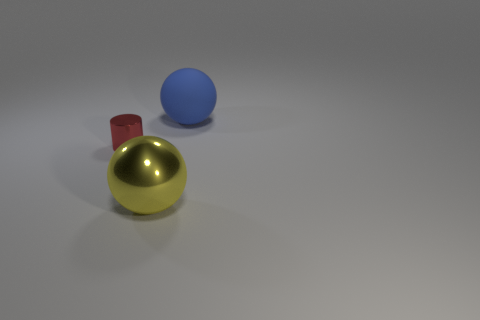There is a object that is in front of the red shiny cylinder; what shape is it?
Give a very brief answer. Sphere. Is the number of small red objects left of the shiny cylinder the same as the number of red cylinders on the left side of the metal ball?
Your answer should be compact. No. How many things are blue spheres or large spheres to the right of the large shiny object?
Offer a very short reply. 1. What shape is the object that is both left of the large rubber thing and behind the big yellow thing?
Offer a terse response. Cylinder. What material is the large sphere right of the large object in front of the blue object?
Provide a succinct answer. Rubber. Do the ball in front of the rubber object and the blue sphere have the same material?
Offer a terse response. No. There is a object in front of the red cylinder; what size is it?
Offer a terse response. Large. There is a matte ball right of the metal sphere; is there a tiny shiny object that is in front of it?
Ensure brevity in your answer.  Yes. The big metallic object has what color?
Your answer should be compact. Yellow. Is there any other thing that has the same color as the metal cylinder?
Keep it short and to the point. No. 